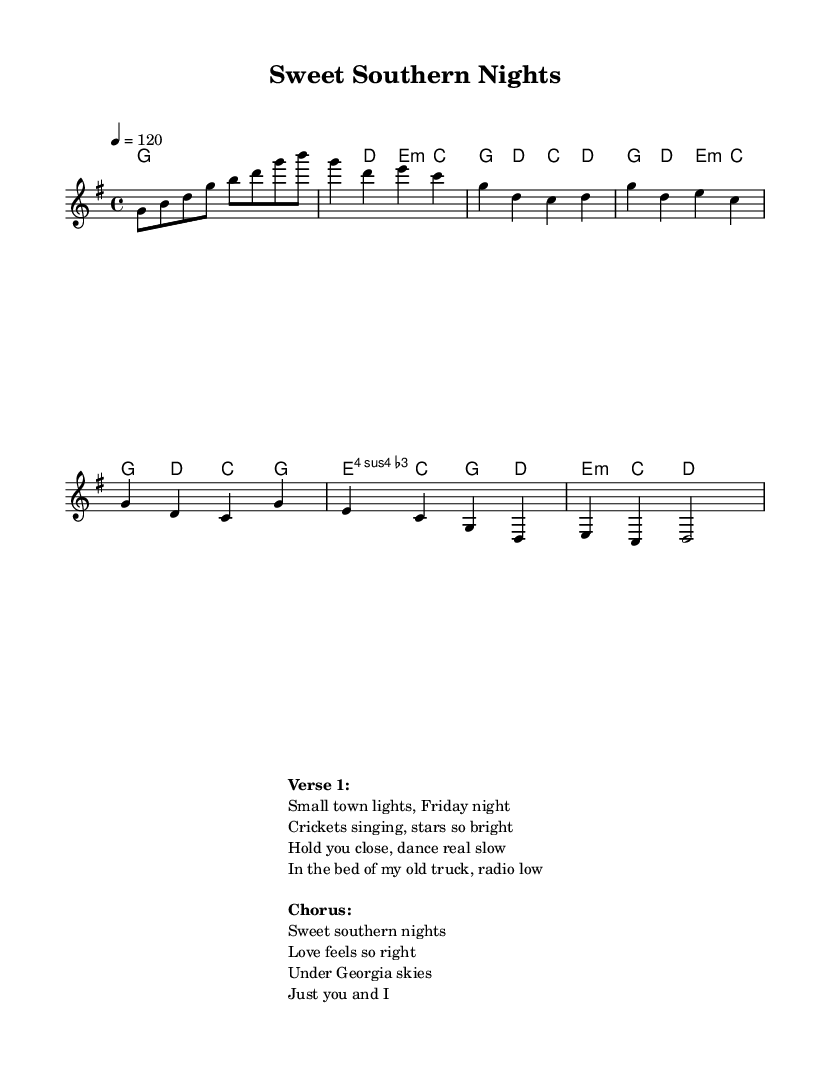What is the key signature of this music? The key signature is G major, which has one sharp (F#). This is identified by observing the relevant key signature at the beginning of the score.
Answer: G major What is the time signature of this music? The time signature is 4/4, as indicated at the start of the score. This indicates there are four beats per measure, and the quarter note gets one beat.
Answer: 4/4 What is the tempo marking of this music? The tempo marking is 120, which tells us to play the tempo at 120 beats per minute. This is found above the staff in the tempo directive section.
Answer: 120 In which section does the chorus start in the music? The chorus starts after the verse, specifically after the lines labeled 'Chorus:' in the lyrics. This indicates a shift from the verses to the prominent part of the song.
Answer: Chorus What chord follows the chord G in the first verse? The chord D follows G in the first verse as indicated in the harmonies section directly after the G chord in the verse.
Answer: D How many measures are there in the bridge section? There are two measures in the bridge section. This can be determined by counting the vertical lines dividing the music notes in that part of the score.
Answer: 2 What musical element is primarily emphasized in R&B songs like this one? The element primarily emphasized is love, specific to small-town life experiences, evident from the lyrics describing love and Southern imagery. This is a hallmark of R&B thematic content.
Answer: Love 